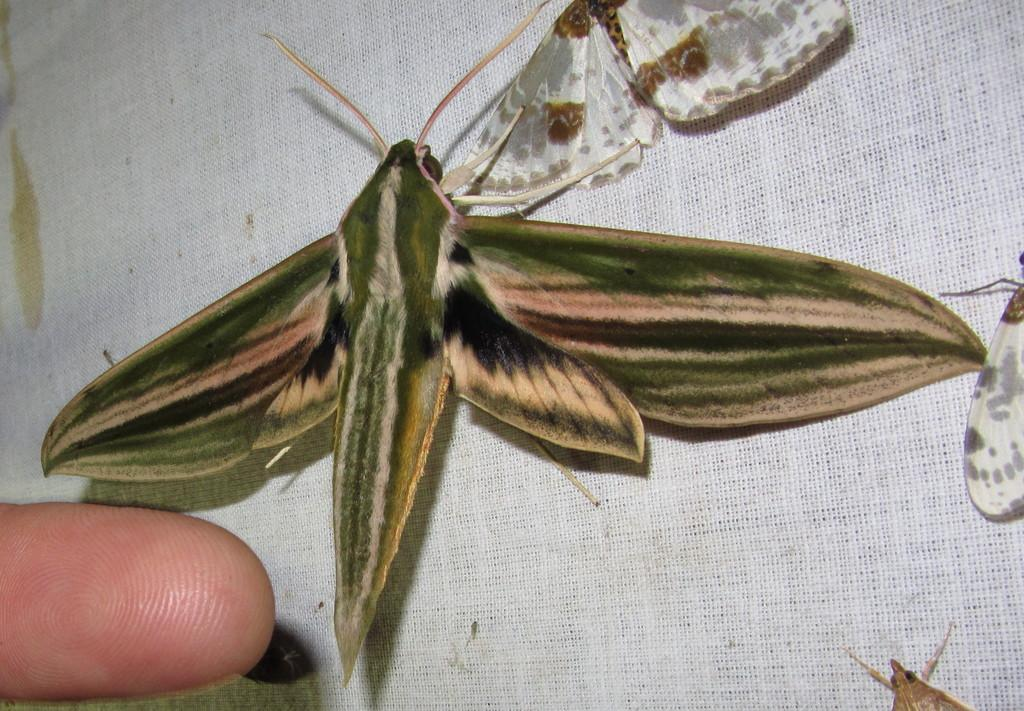What is present on the cloth in the center of the image? There are insects on the cloth in the center of the image. Can you describe anything else visible in the image? There is a finger visible in the bottom left side of the image. What type of sign can be seen near the harbor in the image? There is no sign or harbor present in the image; it only features insects on a cloth and a finger. 